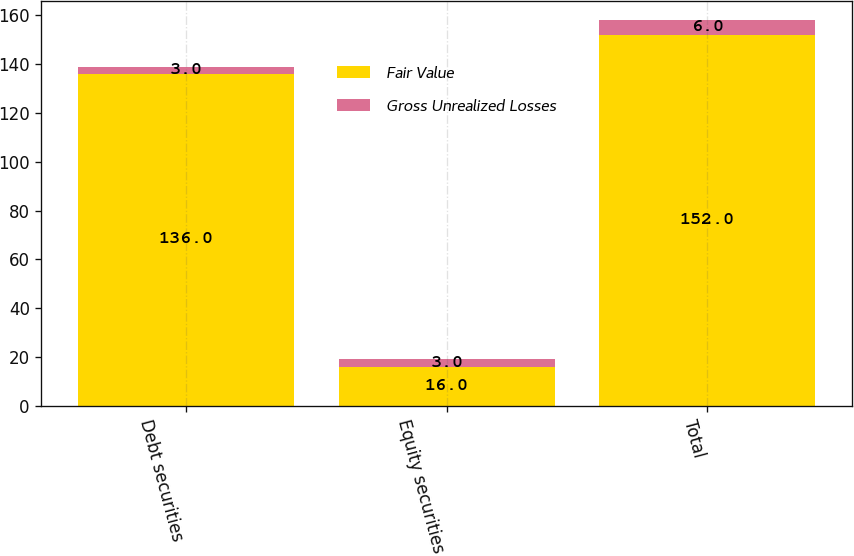Convert chart. <chart><loc_0><loc_0><loc_500><loc_500><stacked_bar_chart><ecel><fcel>Debt securities<fcel>Equity securities<fcel>Total<nl><fcel>Fair Value<fcel>136<fcel>16<fcel>152<nl><fcel>Gross Unrealized Losses<fcel>3<fcel>3<fcel>6<nl></chart> 